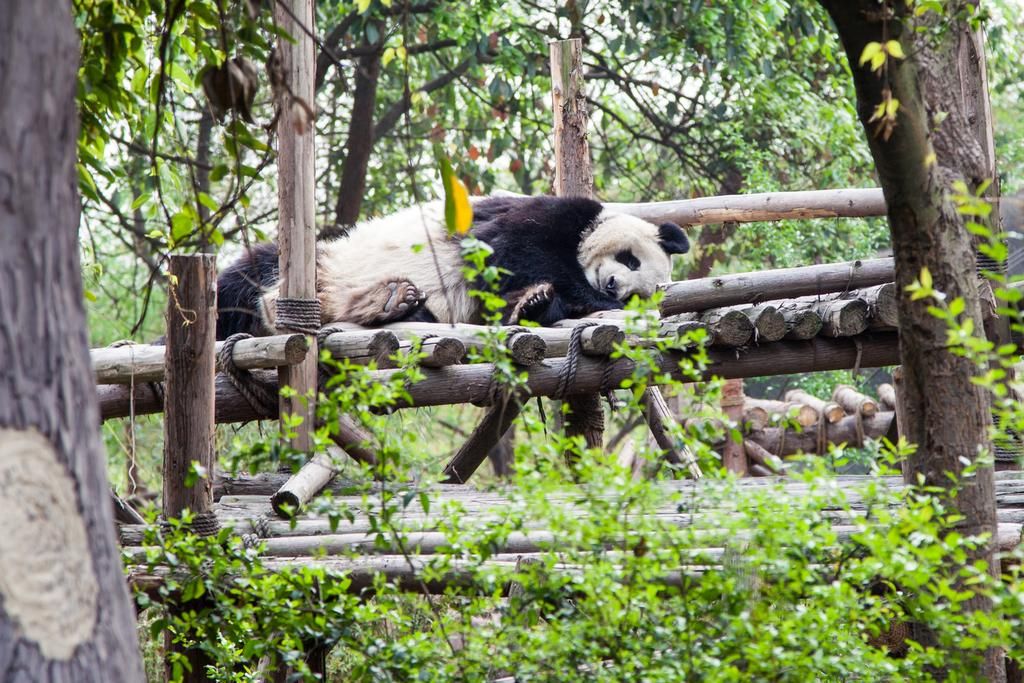What animal is the main subject of the image? There is a polar bear in the image. What is the polar bear lying on? The polar bear is lying on a wooden object. What can be seen in the background of the image? There are wooden poles, trees, plants, and other unspecified objects in the background of the image. What date is circled on the calendar in the image? There is no calendar present in the image. What type of paper is the polar bear holding in the image? There is no paper present in the image; the polar bear is lying on a wooden object. 